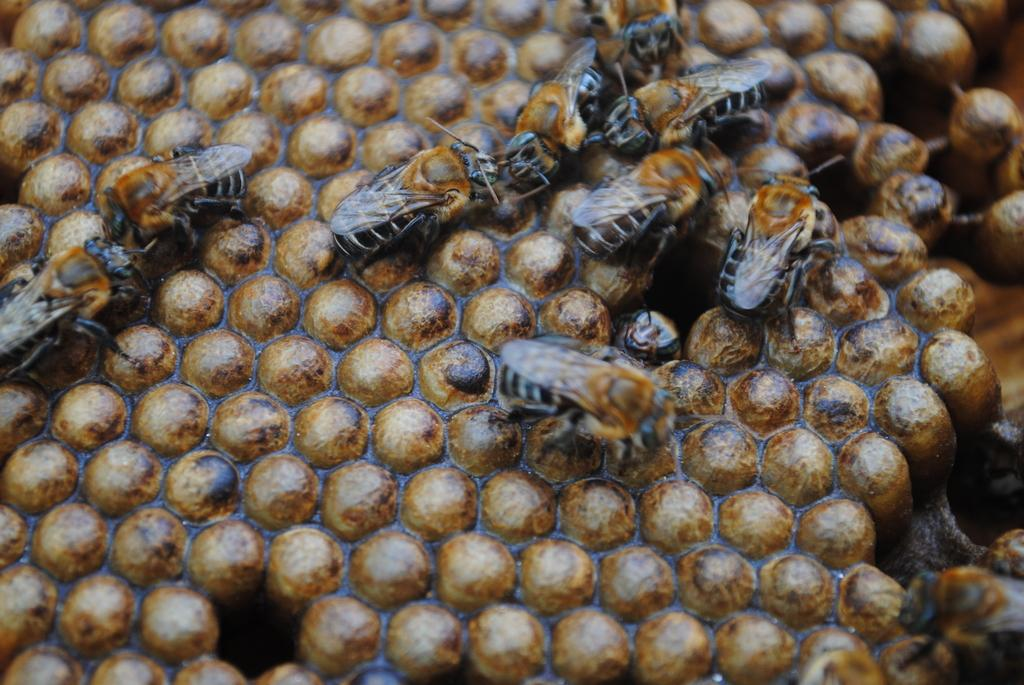What type of insects are present in the image? There are honey bees in the image. What colors are the honey bees? The honey bees are in black and brown color. What structure is visible in the image that is associated with honey bees? There is a honeycomb in the image. What colors are the honeycomb? The honeycomb is in brown and black color. What day of the week is depicted in the image? There is no day of the week depicted in the image, as it features honey bees and a honeycomb. What type of bone can be seen in the image? There is no bone present in the image; it features honey bees and a honeycomb. 